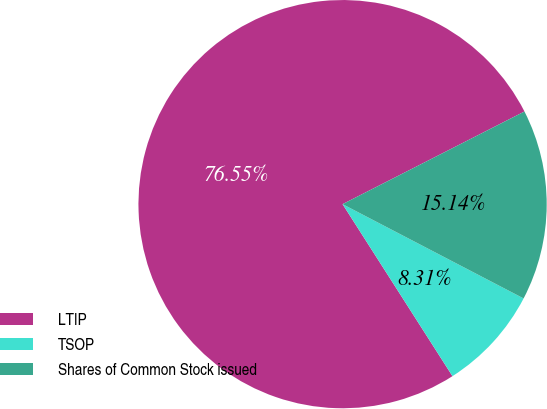<chart> <loc_0><loc_0><loc_500><loc_500><pie_chart><fcel>LTIP<fcel>TSOP<fcel>Shares of Common Stock issued<nl><fcel>76.55%<fcel>8.31%<fcel>15.14%<nl></chart> 